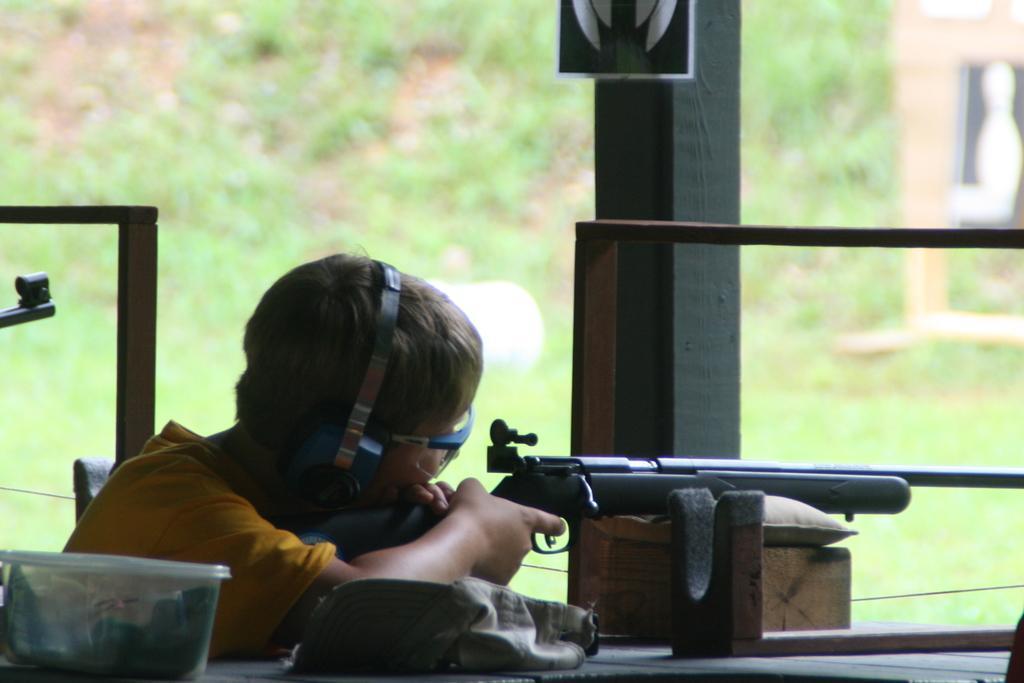Please provide a concise description of this image. In this picture we can see a person, goggles, rock, box, gun, rods, some objects and in the background we can see plants and it is blurry. 